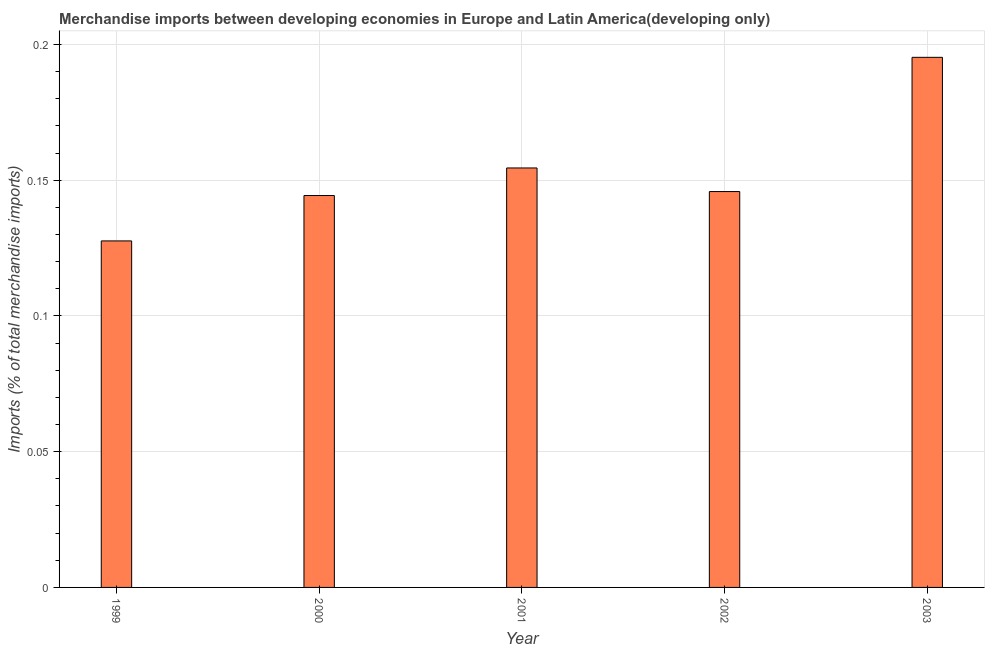Does the graph contain any zero values?
Offer a very short reply. No. What is the title of the graph?
Your answer should be compact. Merchandise imports between developing economies in Europe and Latin America(developing only). What is the label or title of the X-axis?
Your answer should be very brief. Year. What is the label or title of the Y-axis?
Your answer should be compact. Imports (% of total merchandise imports). What is the merchandise imports in 2000?
Your response must be concise. 0.14. Across all years, what is the maximum merchandise imports?
Your answer should be very brief. 0.2. Across all years, what is the minimum merchandise imports?
Your response must be concise. 0.13. In which year was the merchandise imports maximum?
Provide a short and direct response. 2003. In which year was the merchandise imports minimum?
Your answer should be very brief. 1999. What is the sum of the merchandise imports?
Your response must be concise. 0.77. What is the difference between the merchandise imports in 2000 and 2001?
Provide a short and direct response. -0.01. What is the average merchandise imports per year?
Provide a succinct answer. 0.15. What is the median merchandise imports?
Make the answer very short. 0.15. In how many years, is the merchandise imports greater than 0.12 %?
Make the answer very short. 5. Do a majority of the years between 1999 and 2000 (inclusive) have merchandise imports greater than 0.18 %?
Keep it short and to the point. No. What is the ratio of the merchandise imports in 2000 to that in 2003?
Your answer should be compact. 0.74. Is the merchandise imports in 1999 less than that in 2003?
Provide a succinct answer. Yes. Is the difference between the merchandise imports in 2002 and 2003 greater than the difference between any two years?
Your response must be concise. No. What is the difference between the highest and the second highest merchandise imports?
Make the answer very short. 0.04. Is the sum of the merchandise imports in 2001 and 2002 greater than the maximum merchandise imports across all years?
Make the answer very short. Yes. What is the difference between the highest and the lowest merchandise imports?
Your answer should be very brief. 0.07. In how many years, is the merchandise imports greater than the average merchandise imports taken over all years?
Make the answer very short. 2. Are all the bars in the graph horizontal?
Your response must be concise. No. What is the difference between two consecutive major ticks on the Y-axis?
Keep it short and to the point. 0.05. Are the values on the major ticks of Y-axis written in scientific E-notation?
Give a very brief answer. No. What is the Imports (% of total merchandise imports) of 1999?
Give a very brief answer. 0.13. What is the Imports (% of total merchandise imports) in 2000?
Offer a very short reply. 0.14. What is the Imports (% of total merchandise imports) of 2001?
Your answer should be very brief. 0.15. What is the Imports (% of total merchandise imports) in 2002?
Your answer should be very brief. 0.15. What is the Imports (% of total merchandise imports) of 2003?
Offer a terse response. 0.2. What is the difference between the Imports (% of total merchandise imports) in 1999 and 2000?
Give a very brief answer. -0.02. What is the difference between the Imports (% of total merchandise imports) in 1999 and 2001?
Make the answer very short. -0.03. What is the difference between the Imports (% of total merchandise imports) in 1999 and 2002?
Give a very brief answer. -0.02. What is the difference between the Imports (% of total merchandise imports) in 1999 and 2003?
Provide a succinct answer. -0.07. What is the difference between the Imports (% of total merchandise imports) in 2000 and 2001?
Your answer should be very brief. -0.01. What is the difference between the Imports (% of total merchandise imports) in 2000 and 2002?
Make the answer very short. -0. What is the difference between the Imports (% of total merchandise imports) in 2000 and 2003?
Ensure brevity in your answer.  -0.05. What is the difference between the Imports (% of total merchandise imports) in 2001 and 2002?
Offer a very short reply. 0.01. What is the difference between the Imports (% of total merchandise imports) in 2001 and 2003?
Give a very brief answer. -0.04. What is the difference between the Imports (% of total merchandise imports) in 2002 and 2003?
Your answer should be compact. -0.05. What is the ratio of the Imports (% of total merchandise imports) in 1999 to that in 2000?
Keep it short and to the point. 0.88. What is the ratio of the Imports (% of total merchandise imports) in 1999 to that in 2001?
Ensure brevity in your answer.  0.83. What is the ratio of the Imports (% of total merchandise imports) in 1999 to that in 2003?
Your answer should be compact. 0.65. What is the ratio of the Imports (% of total merchandise imports) in 2000 to that in 2001?
Keep it short and to the point. 0.93. What is the ratio of the Imports (% of total merchandise imports) in 2000 to that in 2003?
Make the answer very short. 0.74. What is the ratio of the Imports (% of total merchandise imports) in 2001 to that in 2002?
Your answer should be compact. 1.06. What is the ratio of the Imports (% of total merchandise imports) in 2001 to that in 2003?
Ensure brevity in your answer.  0.79. What is the ratio of the Imports (% of total merchandise imports) in 2002 to that in 2003?
Provide a short and direct response. 0.75. 